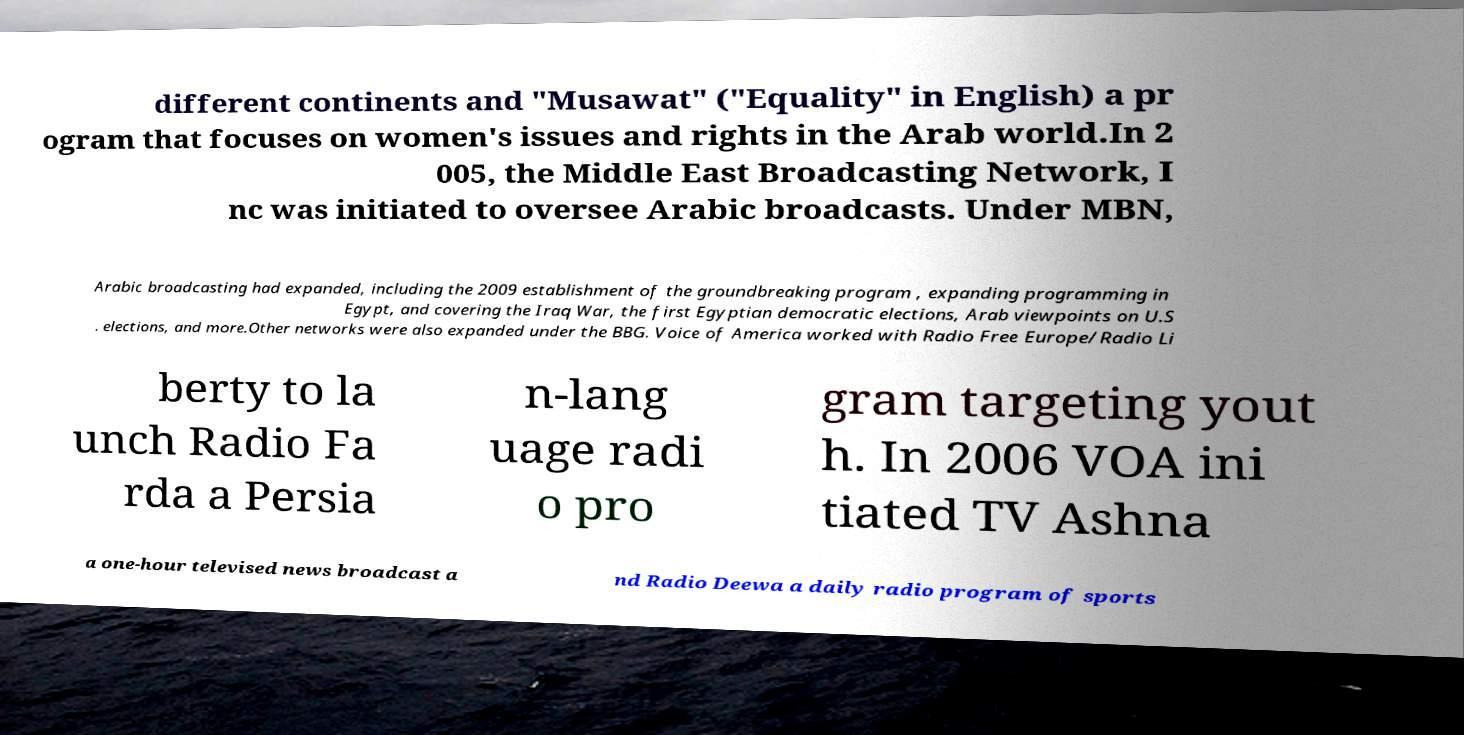Please identify and transcribe the text found in this image. different continents and "Musawat" ("Equality" in English) a pr ogram that focuses on women's issues and rights in the Arab world.In 2 005, the Middle East Broadcasting Network, I nc was initiated to oversee Arabic broadcasts. Under MBN, Arabic broadcasting had expanded, including the 2009 establishment of the groundbreaking program , expanding programming in Egypt, and covering the Iraq War, the first Egyptian democratic elections, Arab viewpoints on U.S . elections, and more.Other networks were also expanded under the BBG. Voice of America worked with Radio Free Europe/Radio Li berty to la unch Radio Fa rda a Persia n-lang uage radi o pro gram targeting yout h. In 2006 VOA ini tiated TV Ashna a one-hour televised news broadcast a nd Radio Deewa a daily radio program of sports 